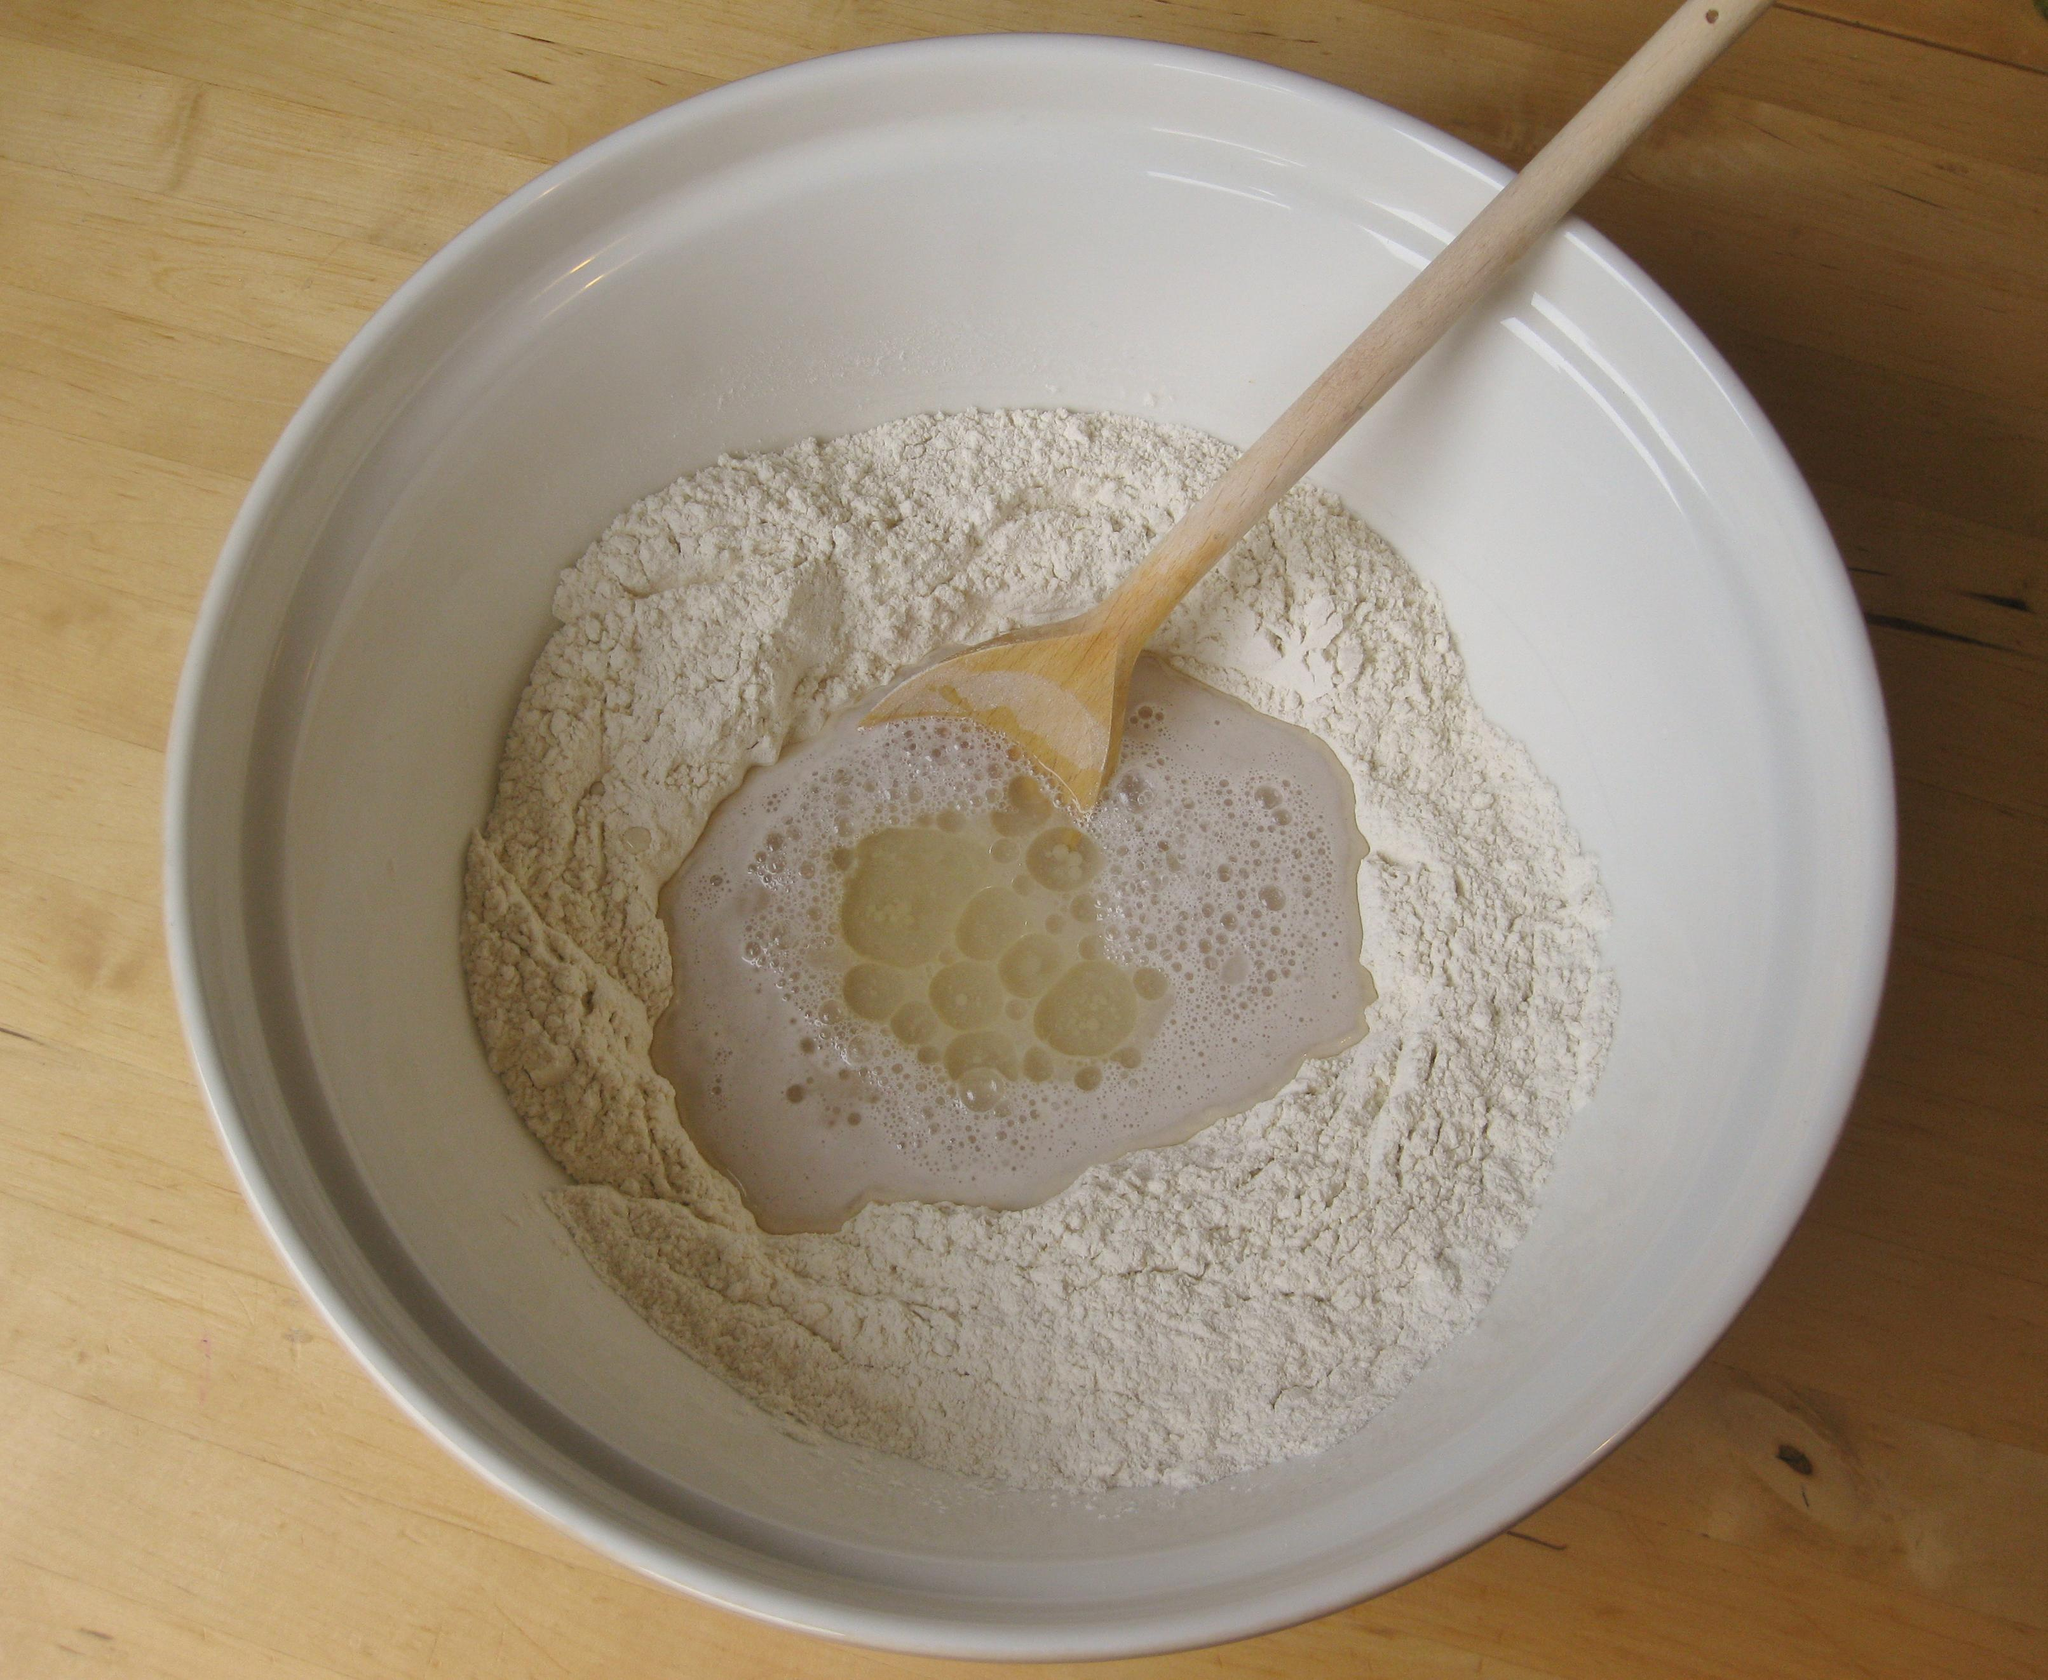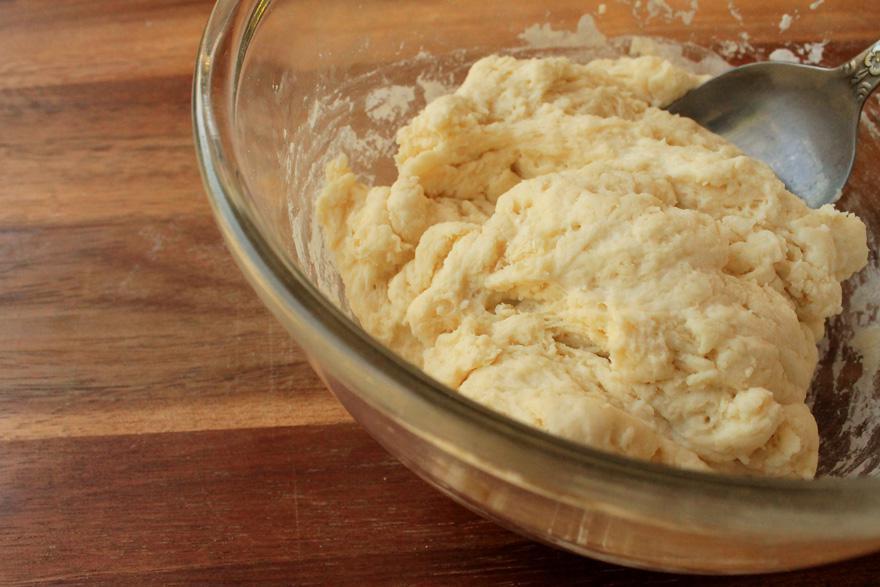The first image is the image on the left, the second image is the image on the right. Assess this claim about the two images: "Only one wooden spoon is visible.". Correct or not? Answer yes or no. Yes. The first image is the image on the left, the second image is the image on the right. Examine the images to the left and right. Is the description "In one of the images, the dough is being stirred by a mixer." accurate? Answer yes or no. No. 